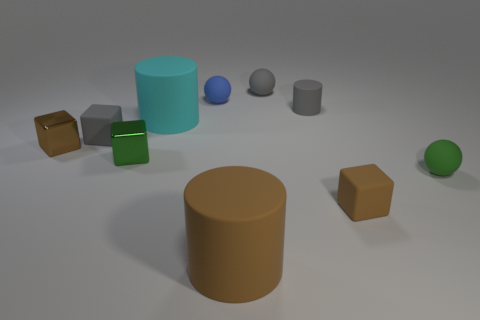What is the material of the green block?
Ensure brevity in your answer.  Metal. What material is the big object that is in front of the big cylinder behind the small brown metallic block left of the large cyan thing?
Make the answer very short. Rubber. Is the color of the small matte cylinder the same as the ball behind the blue matte ball?
Give a very brief answer. Yes. The big rubber cylinder that is in front of the matte ball in front of the tiny gray cylinder is what color?
Provide a succinct answer. Brown. What number of tiny shiny things are there?
Your response must be concise. 2. What number of metal things are large cyan cylinders or large cylinders?
Make the answer very short. 0. What number of small matte balls are the same color as the small rubber cylinder?
Your answer should be compact. 1. What material is the green object that is behind the tiny sphere on the right side of the tiny brown matte thing made of?
Your response must be concise. Metal. What size is the green metal cube?
Offer a terse response. Small. What number of purple rubber balls have the same size as the gray cube?
Give a very brief answer. 0. 